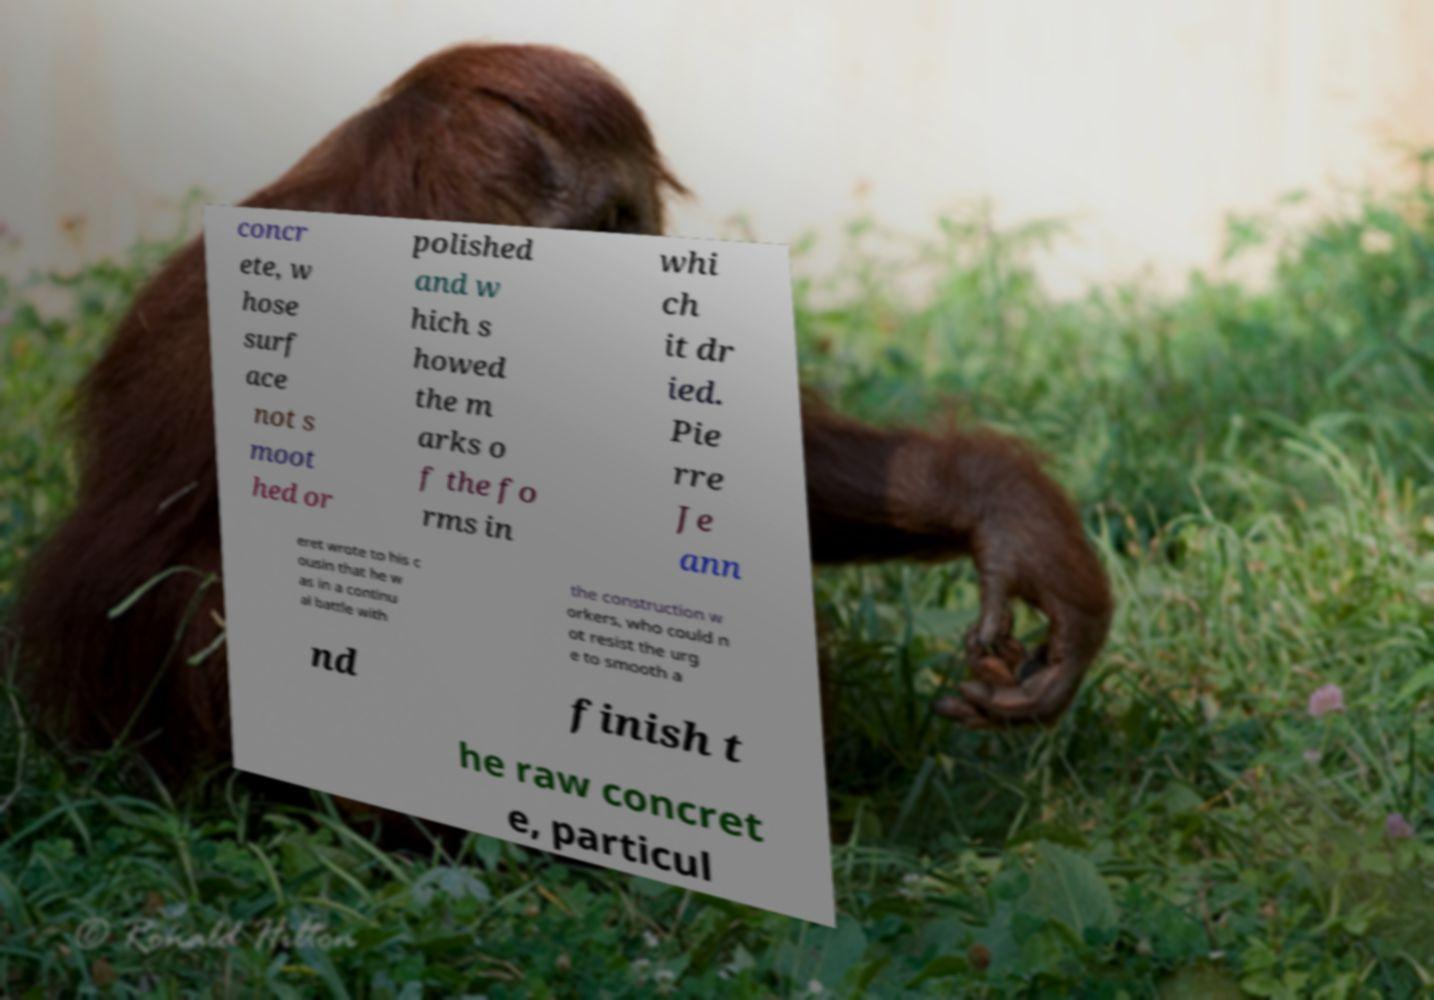Can you accurately transcribe the text from the provided image for me? concr ete, w hose surf ace not s moot hed or polished and w hich s howed the m arks o f the fo rms in whi ch it dr ied. Pie rre Je ann eret wrote to his c ousin that he w as in a continu al battle with the construction w orkers, who could n ot resist the urg e to smooth a nd finish t he raw concret e, particul 